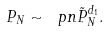<formula> <loc_0><loc_0><loc_500><loc_500>P _ { N } \sim \ p n \tilde { P } _ { N } ^ { d _ { 1 } } .</formula> 